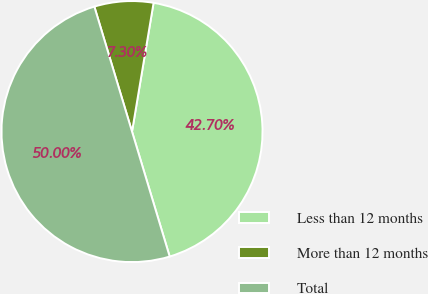<chart> <loc_0><loc_0><loc_500><loc_500><pie_chart><fcel>Less than 12 months<fcel>More than 12 months<fcel>Total<nl><fcel>42.7%<fcel>7.3%<fcel>50.0%<nl></chart> 